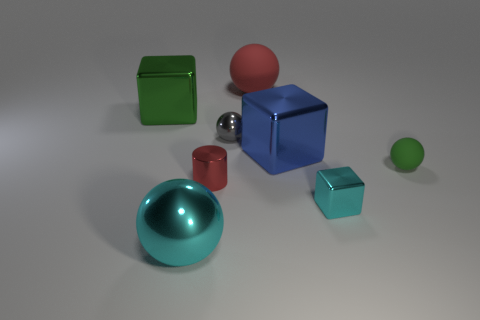Subtract 1 balls. How many balls are left? 3 Add 1 tiny red shiny cylinders. How many objects exist? 9 Subtract all cylinders. How many objects are left? 7 Subtract 1 green spheres. How many objects are left? 7 Subtract all small cyan metallic blocks. Subtract all cyan objects. How many objects are left? 5 Add 5 small cyan things. How many small cyan things are left? 6 Add 2 large green metal cubes. How many large green metal cubes exist? 3 